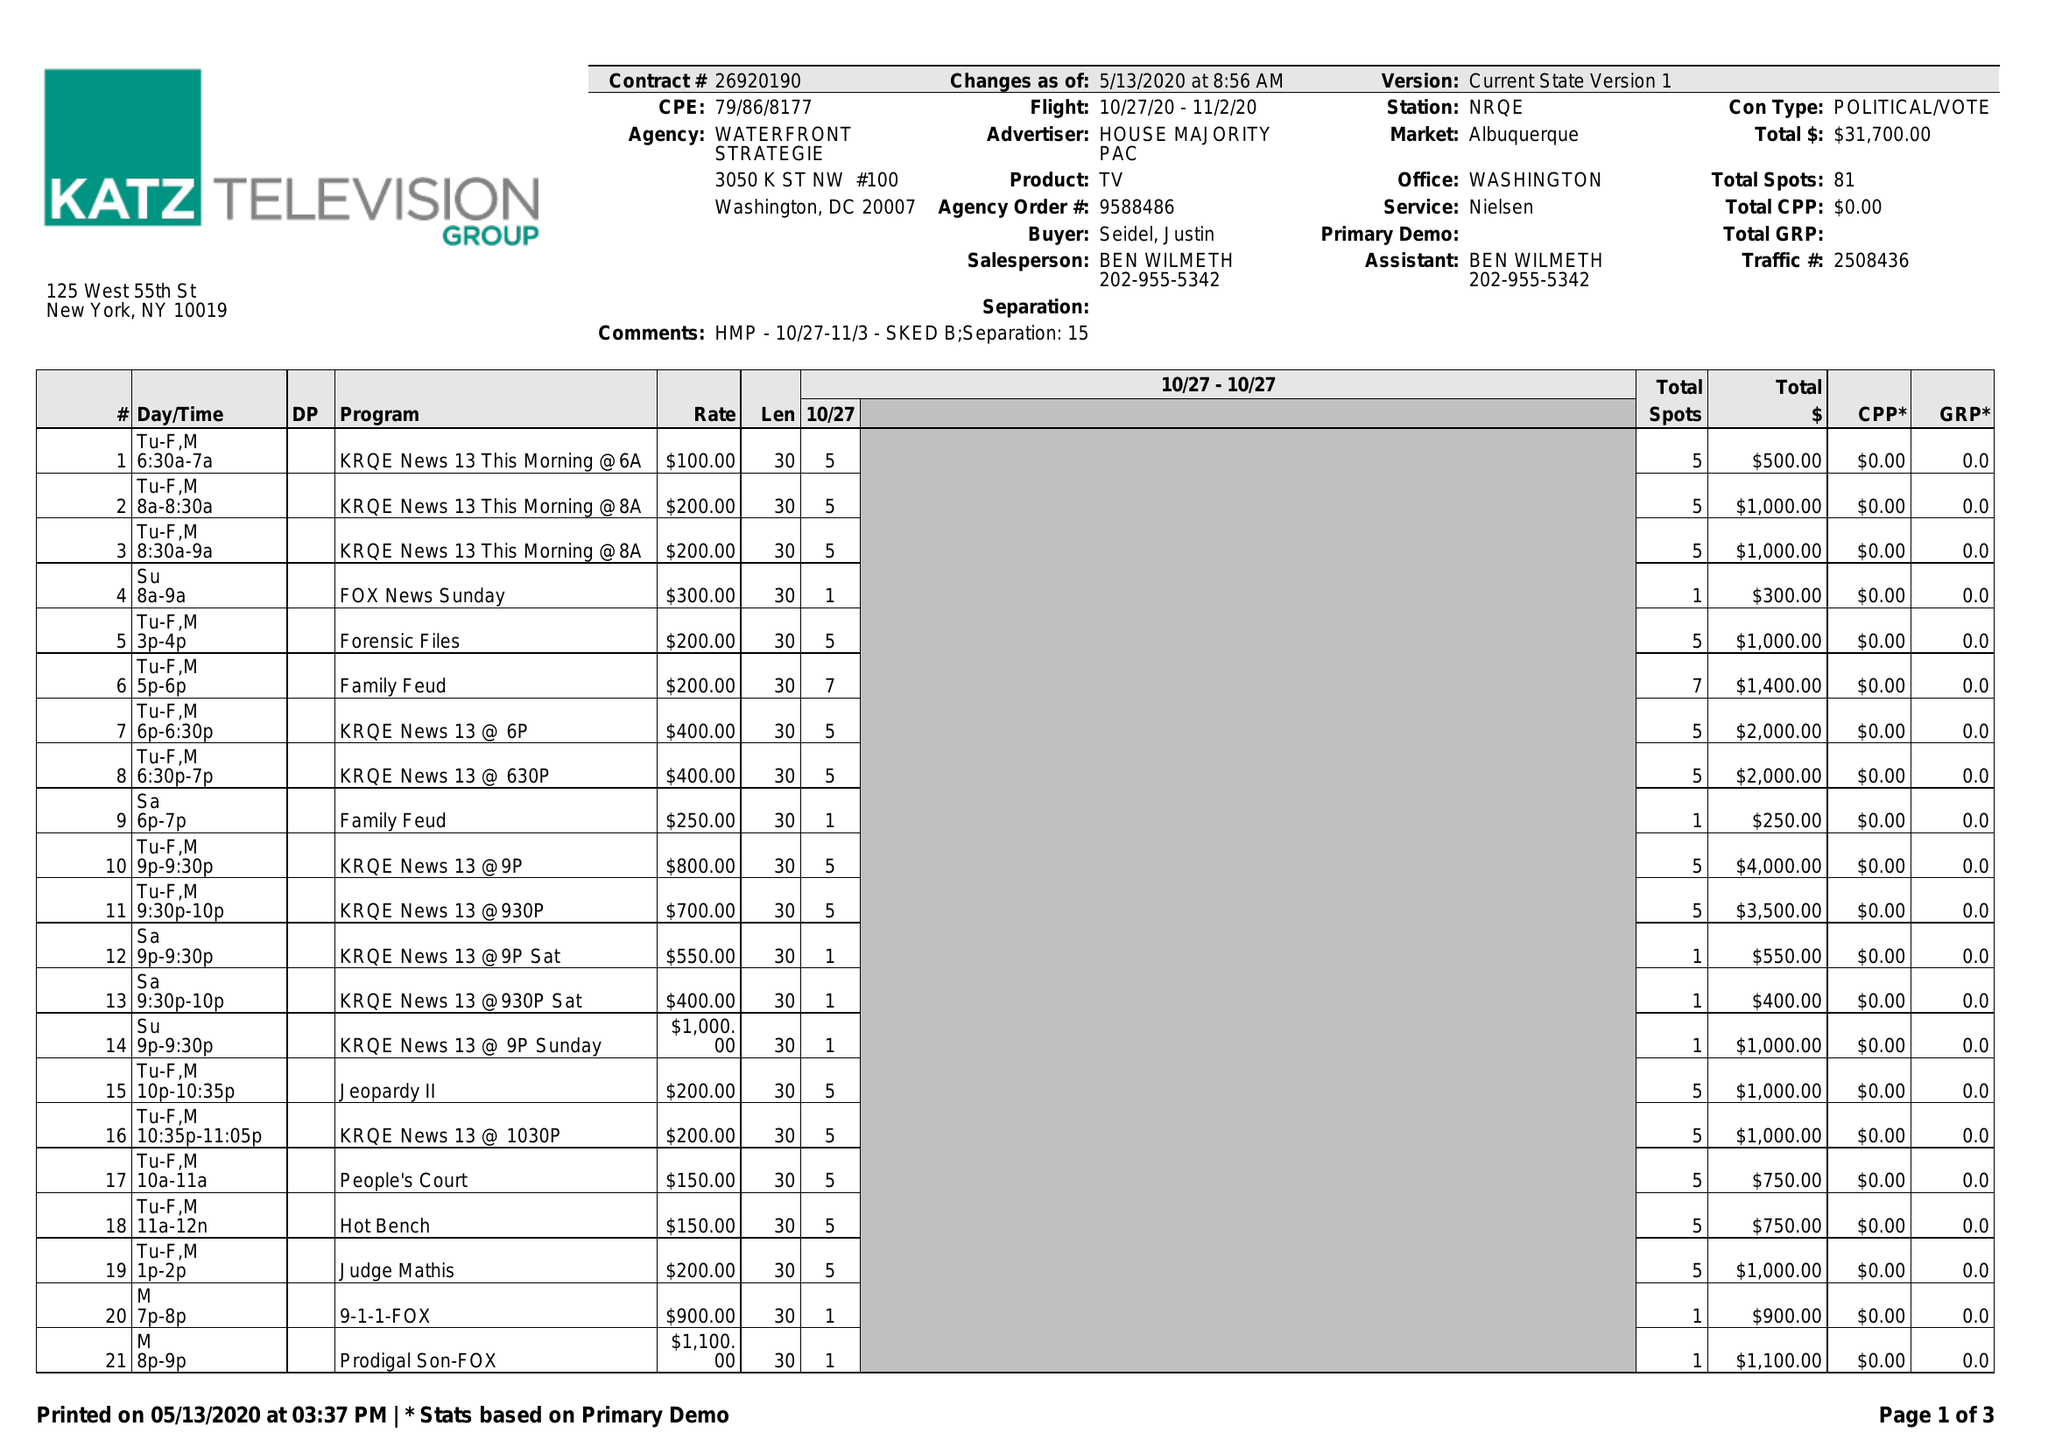What is the value for the contract_num?
Answer the question using a single word or phrase. 26920190 